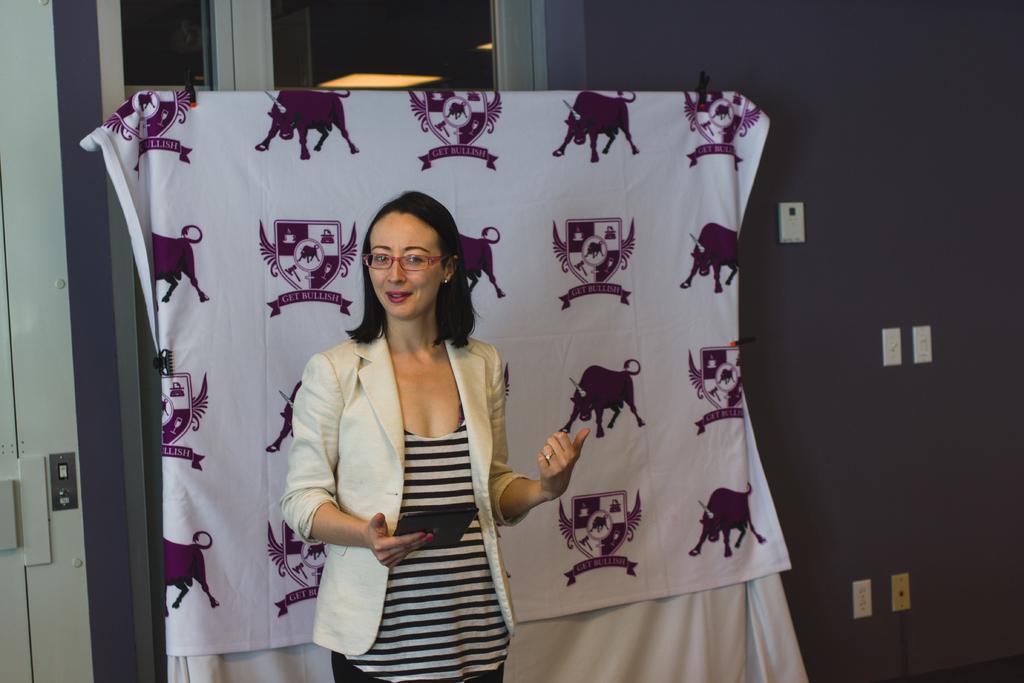Can you describe this image briefly? In this image I can see a woman wearing white, black and cream colored dress is standing and holding a black colored object. I can see a white colored cloth behind her, the wall and few switches to the wall. 